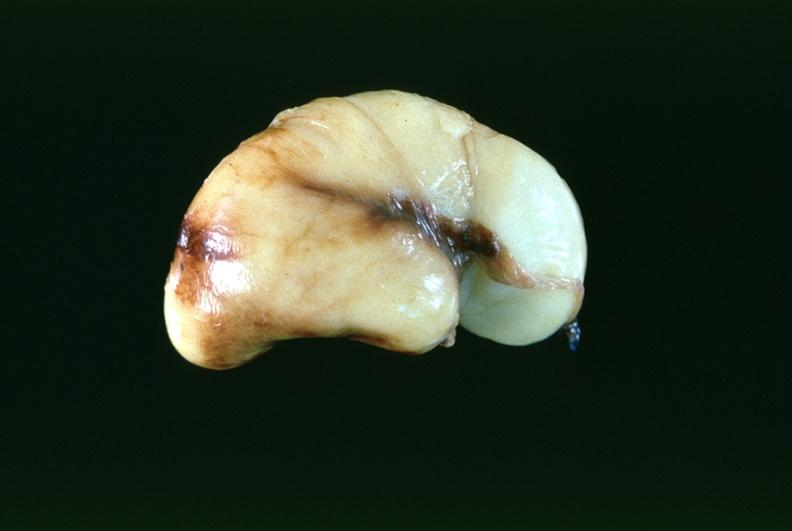s color present?
Answer the question using a single word or phrase. No 